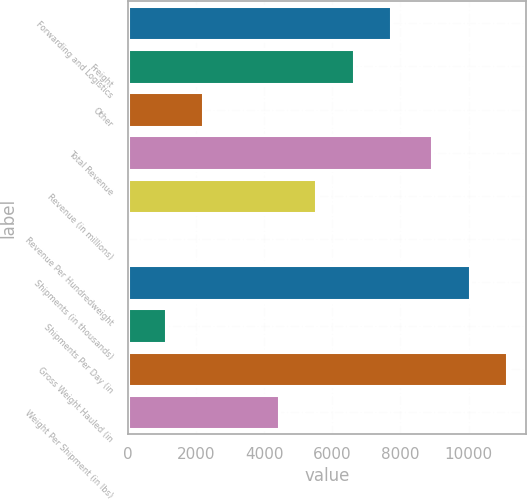<chart> <loc_0><loc_0><loc_500><loc_500><bar_chart><fcel>Forwarding and Logistics<fcel>Freight<fcel>Other<fcel>Total Revenue<fcel>Revenue (in millions)<fcel>Revenue Per Hundredweight<fcel>Shipments (in thousands)<fcel>Shipments Per Day (in<fcel>Gross Weight Hauled (in<fcel>Weight Per Shipment (in lbs)<nl><fcel>7731.49<fcel>6629.66<fcel>2222.34<fcel>8915<fcel>5527.83<fcel>18.68<fcel>10036<fcel>1120.51<fcel>11137.8<fcel>4426<nl></chart> 